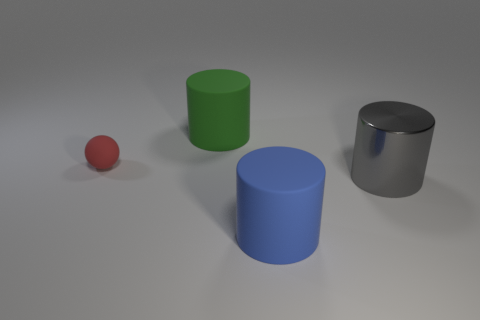Is there any other thing that has the same shape as the large gray shiny object?
Provide a succinct answer. Yes. How many objects are cyan shiny balls or rubber cylinders?
Ensure brevity in your answer.  2. What size is the other metallic object that is the same shape as the large blue object?
Keep it short and to the point. Large. Is there anything else that is the same size as the red rubber object?
Offer a terse response. No. What number of other objects are the same color as the rubber ball?
Provide a succinct answer. 0. How many cylinders are large purple objects or large green rubber objects?
Your answer should be compact. 1. There is a large rubber cylinder that is in front of the large cylinder that is behind the tiny rubber sphere; what color is it?
Make the answer very short. Blue. What is the shape of the gray metallic thing?
Offer a terse response. Cylinder. Does the rubber cylinder behind the red matte object have the same size as the big blue object?
Offer a very short reply. Yes. Is there a big yellow object that has the same material as the big gray object?
Your answer should be very brief. No. 